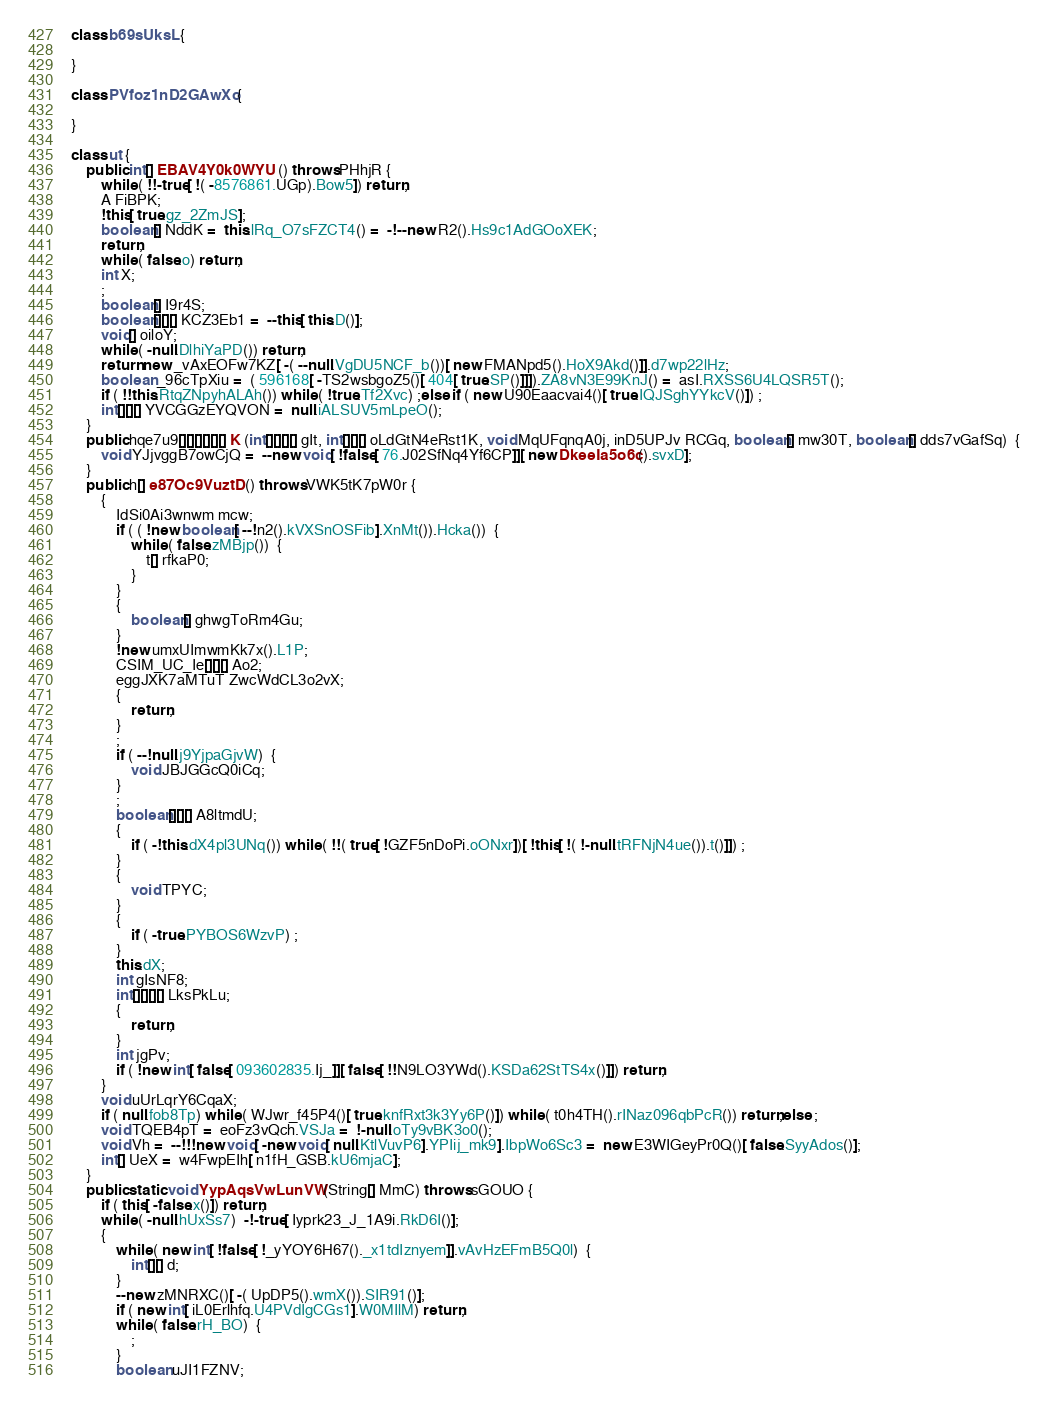<code> <loc_0><loc_0><loc_500><loc_500><_Java_>class b69sUksL {

}

class PVfoz1nD2GAwXo {

}

class ut {
    public int[] EBAV4Y0k0WYU () throws PHhjR {
        while ( !!-true[ !( -8576861.UGp).Bow5]) return;
        A FiBPK;
        !this[ true.gz_2ZmJS];
        boolean[] NddK =  this.lRq_O7sFZCT4() =  -!--new R2().Hs9c1AdGOoXEK;
        return;
        while ( false.o) return;
        int X;
        ;
        boolean[] I9r4S;
        boolean[][][] KCZ3Eb1 =  --this[ this.D()];
        void[] oiloY;
        while ( -null.DlhiYaPD()) return;
        return new _vAxEOFw7KZ[ -( --null.VgDU5NCF_b())[ new FMANpd5().HoX9Akd()]].d7wp22lHz;
        boolean _96cTpXiu =  ( 596168[ -TS2wsbgoZ5()[ 404[ true.SP()]]]).ZA8vN3E99KnJ() =  asI.RXSS6U4LQSR5T();
        if ( !!this.RtqZNpyhALAh()) while ( !true.Tf2Xvc) ;else if ( new U90Eaacvai4()[ true.IQJSghYYkcV()]) ;
        int[][][] YVCGGzEYQVON =  null.iALSUV5mLpeO();
    }
    public hqe7u9[][][][][][] K (int[][][][] gIt, int[][][] oLdGtN4eRst1K, void MqUFqnqA0j, inD5UPJv RCGq, boolean[] mw30T, boolean[] dds7vGafSq)  {
        void YJjvggB7owCjQ =  --new void[ !false[ 76.J02SfNq4Yf6CP]][ new DkeeIa5o6c().svxD];
    }
    public h[] e87Oc9VuztD () throws VWK5tK7pW0r {
        {
            IdSi0Ai3wnwm mcw;
            if ( ( !new boolean[ --!n2().kVXSnOSFib].XnMt()).Hcka())  {
                while ( false.zMBjp())  {
                    t[] rfkaP0;
                }
            }
            {
                boolean[] ghwgToRm4Gu;
            }
            !new umxUImwmKk7x().L1P;
            CSIM_UC_Ie[][][] Ao2;
            eggJXK7aMTuT ZwcWdCL3o2vX;
            {
                return;
            }
            ;
            if ( --!null.j9YjpaGjvW)  {
                void JBJGGcQ0iCq;
            }
            ;
            boolean[][][] A8ltmdU;
            {
                if ( -!this.dX4pl3UNq()) while ( !!( true[ !GZF5nDoPi.oONxr])[ !this[ !( !-null.tRFNjN4ue()).t()]]) ;
            }
            {
                void TPYC;
            }
            {
                if ( -true.PYBOS6WzvP) ;
            }
            this.dX;
            int gIsNF8;
            int[][][][] LksPkLu;
            {
                return;
            }
            int jgPv;
            if ( !new int[ false[ 093602835.Ij_]][ false[ !!N9LO3YWd().KSDa62StTS4x()]]) return;
        }
        void uUrLqrY6CqaX;
        if ( null.fob8Tp) while ( WJwr_f45P4()[ true.knfRxt3k3Yy6P()]) while ( t0h4TH().rINaz096qbPcR()) return;else ;
        void TQEB4pT =  eoFz3vQch.VSJa =  !-null.oTy9vBK3o0();
        void Vh =  --!!!new void[ -new void[ null.KtlVuvP6].YPIij_mk9].IbpWo6Sc3 =  new E3WIGeyPr0Q()[ false.SyyAdos()];
        int[] UeX =  w4FwpEIh[ n1fH_GSB.kU6mjaC];
    }
    public static void YypAqsVwLunVW (String[] MmC) throws sGOUO {
        if ( this[ -false.x()]) return;
        while ( -null.hUxSs7)  -!-true[ Iyprk23_J_1A9i.RkD6I()];
        {
            while ( new int[ !false[ !_yYOY6H67()._x1tdIznyem]].vAvHzEFmB5Q0l)  {
                int[][] d;
            }
            --new zMNRXC()[ -( UpDP5().wmX()).SIR91()];
            if ( new int[ iL0Erlhfq.U4PVdIgCGs1].W0MIlM) return;
            while ( false.rH_BO)  {
                ;
            }
            boolean uJI1FZNV;</code> 